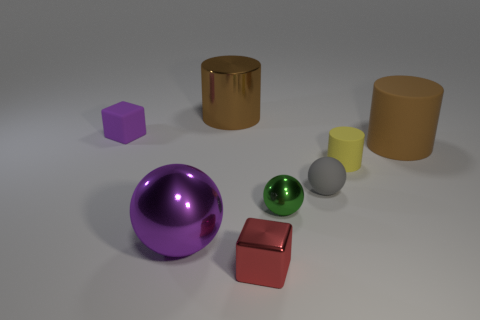What is the size of the thing that is the same color as the big metallic cylinder?
Give a very brief answer. Large. What is the color of the tiny ball that is behind the green object?
Keep it short and to the point. Gray. There is a small green object; is its shape the same as the purple thing to the left of the purple sphere?
Your response must be concise. No. Are there any large rubber things that have the same color as the small cylinder?
Offer a very short reply. No. What size is the brown thing that is made of the same material as the big purple ball?
Provide a short and direct response. Large. Does the big rubber thing have the same color as the metallic cylinder?
Offer a very short reply. Yes. There is a purple object in front of the small green shiny sphere; is it the same shape as the gray matte object?
Make the answer very short. Yes. What number of brown metal things are the same size as the rubber cube?
Your answer should be very brief. 0. The tiny rubber object that is the same color as the big sphere is what shape?
Keep it short and to the point. Cube. There is a sphere that is on the right side of the tiny green ball; are there any big brown objects that are right of it?
Offer a terse response. Yes. 